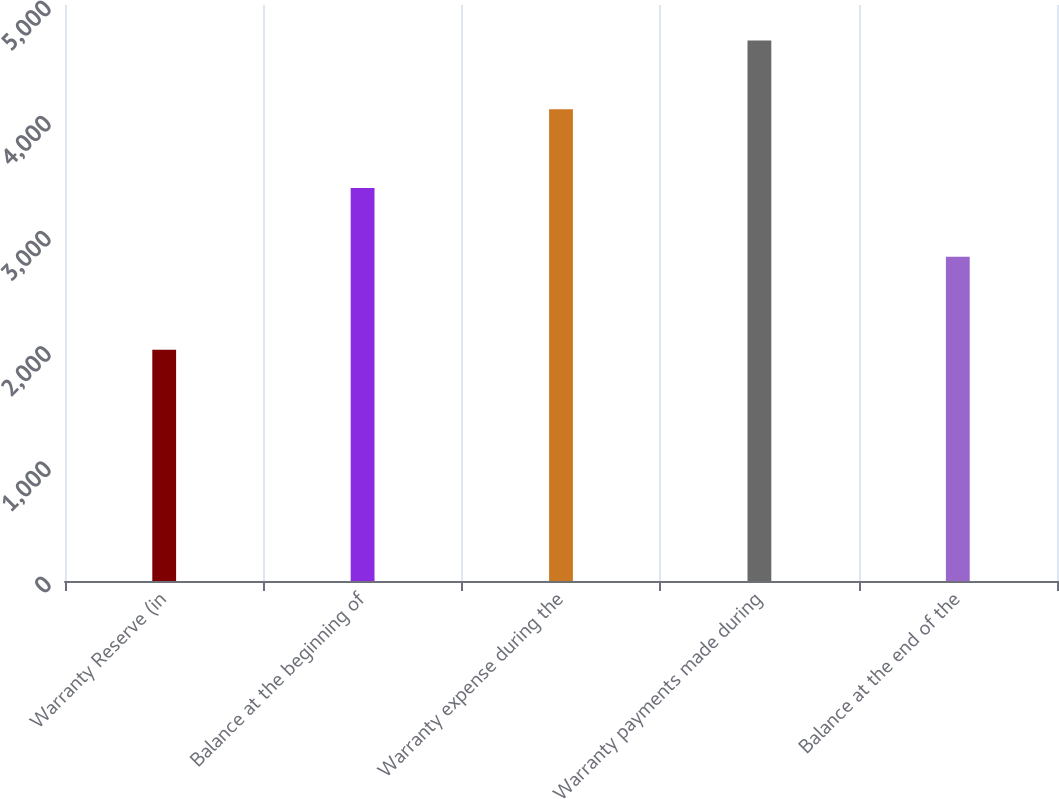Convert chart to OTSL. <chart><loc_0><loc_0><loc_500><loc_500><bar_chart><fcel>Warranty Reserve (in<fcel>Balance at the beginning of<fcel>Warranty expense during the<fcel>Warranty payments made during<fcel>Balance at the end of the<nl><fcel>2008<fcel>3411<fcel>4094<fcel>4691<fcel>2814<nl></chart> 